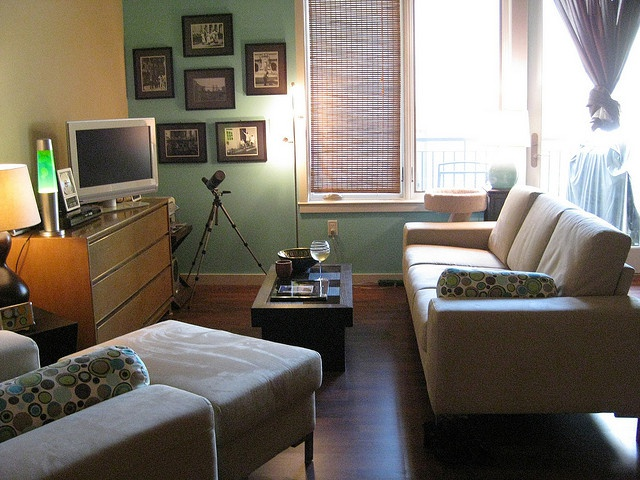Describe the objects in this image and their specific colors. I can see couch in gray, black, and white tones, couch in gray, black, and darkgray tones, couch in gray, black, and darkgray tones, tv in gray, black, and darkgray tones, and bowl in gray, black, darkgreen, and white tones in this image. 